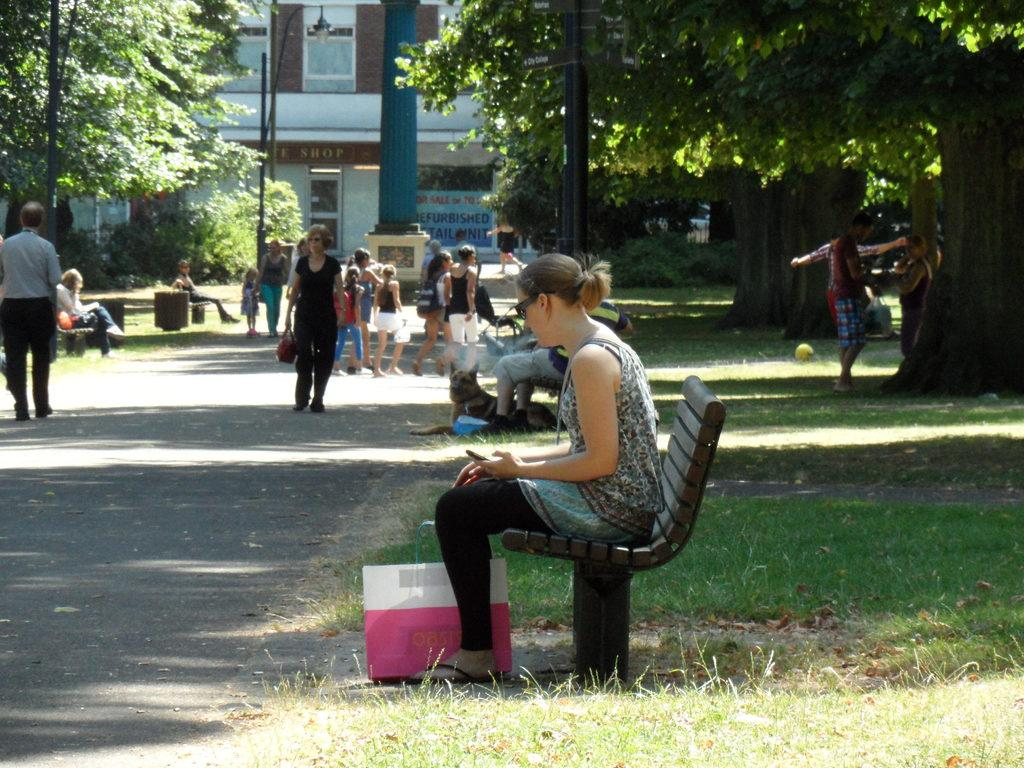Who is the main subject in the image? There is a woman in the image. What is the woman doing in the image? The woman is sitting on a bench. Are there any other people in the image? Yes, there are people standing behind the woman. What invention can be seen in the hands of the woman in the image? There is no invention visible in the woman's hands in the image. What star is shining brightly in the background of the image? There is no star visible in the image; it is focused on the woman and the people standing behind her. 